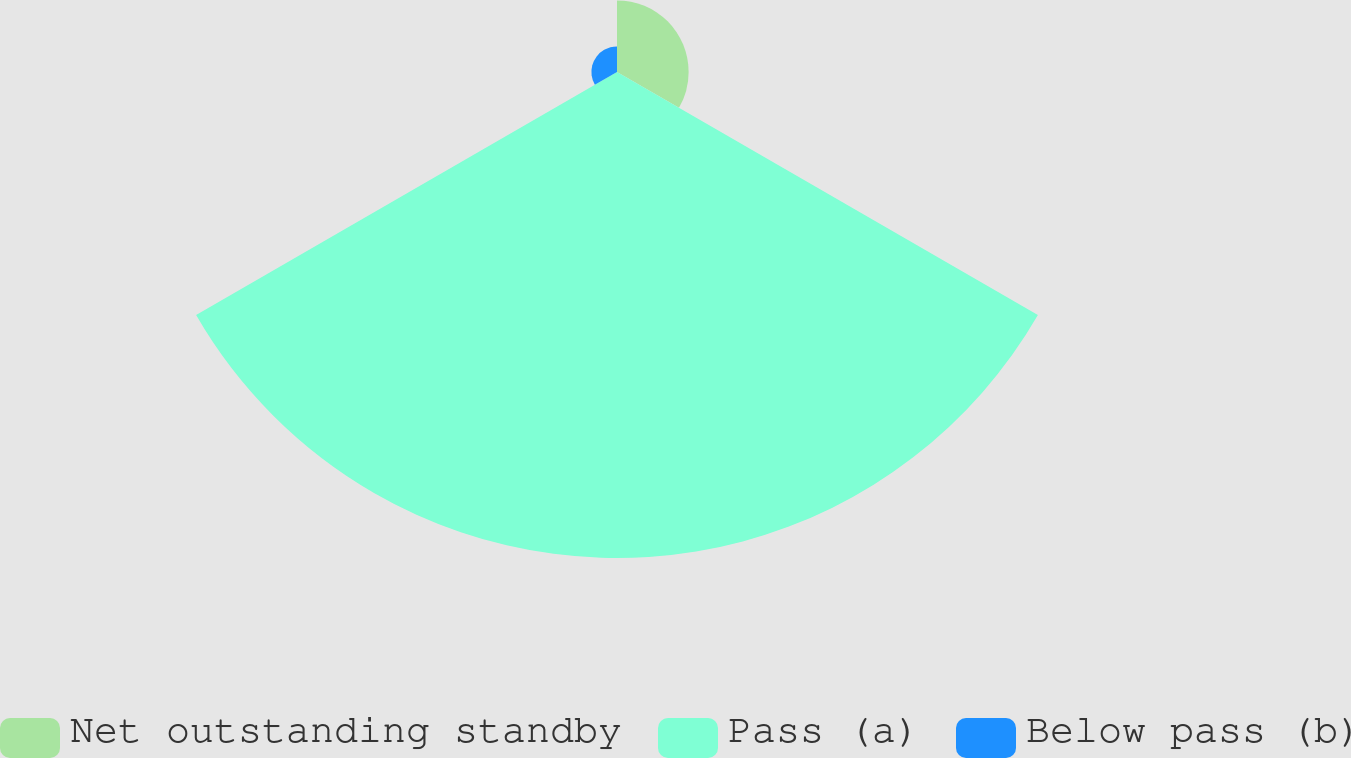<chart> <loc_0><loc_0><loc_500><loc_500><pie_chart><fcel>Net outstanding standby<fcel>Pass (a)<fcel>Below pass (b)<nl><fcel>12.28%<fcel>83.33%<fcel>4.39%<nl></chart> 